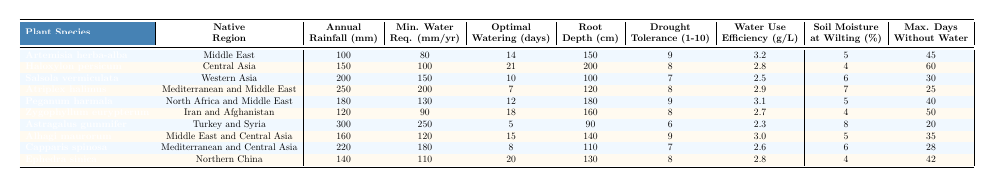What is the native region of Artemisia herba-alba? The table lists the native region for each plant species. For Artemisia herba-alba, the native region is specified as "Middle East."
Answer: Middle East Which plant has the highest minimum water requirement? The minimum water requirement for each plant is noted in the table. The maximum value is 250 mm/year for Astragalus gummifer.
Answer: Astragalus gummifer What is the average annual rainfall of the plants listed? To find the average, sum the annual rainfall values: (100 + 150 + 200 + 250 + 180 + 120 + 300 + 160 + 220 + 140) = 1820 mm, then divide by 10 (the number of plants): 1820/10 = 182 mm.
Answer: 182 mm Is the maximum days without water for Haloxylon persicum greater than 50? The maximum days without water for Haloxylon persicum is 60, which is indeed greater than 50.
Answer: Yes Which plant has the lowest root depth, and what is that depth? Reviewing the root depth data, Salsola vermiculata has the lowest root depth of 100 cm.
Answer: Salsola vermiculata, 100 cm If you combined the minimum water requirements for Atriplex halimus and Capparis spinosa, what would the total be? The minimum water requirement for Atriplex halimus is 200 mm/year and for Capparis spinosa is 180 mm/year. Adding these gives 200 + 180 = 380 mm/year.
Answer: 380 mm/year How many days does Peganum harmala require for optimal watering? The table indicates that Peganum harmala has an optimal watering frequency of 12 days.
Answer: 12 days Which plant species has the highest drought tolerance index? By comparing the drought tolerance index values, Artemisia herba-alba and Peganum harmala both score 9, which is the highest.
Answer: Artemisia herba-alba and Peganum harmala What is the average water use efficiency of the plants listed? First, sum the water use efficiency values: (3.2 + 2.8 + 2.5 + 2.9 + 3.1 + 2.7 + 2.3 + 3.0 + 2.6 + 2.8) = 27.9 g/L, and then divide by 10: 27.9/10 = 2.79 g/L.
Answer: 2.79 g/L Are there any plants with a minimum water requirement of less than 100 mm/year? The minimum water requirements are checked and Haloxylon persicum has a minimum water requirement exactly at 100 mm/year, but none are below 100 mm/year.
Answer: No 